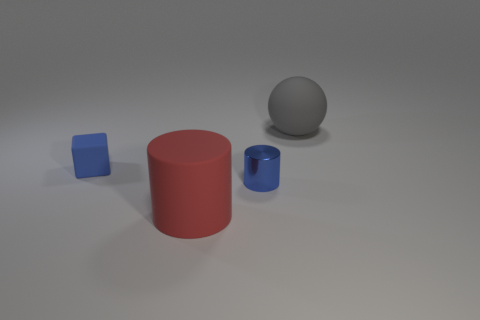Is there any other thing that is made of the same material as the blue cylinder?
Offer a very short reply. No. Is the color of the tiny object on the right side of the red matte thing the same as the large rubber object that is behind the metal cylinder?
Make the answer very short. No. What number of blocks are either tiny brown matte objects or small things?
Provide a succinct answer. 1. Are there the same number of big rubber things that are to the left of the blue cylinder and tiny objects?
Your answer should be very brief. No. What is the big object in front of the rubber thing to the left of the matte thing that is in front of the small blue matte thing made of?
Ensure brevity in your answer.  Rubber. There is a cylinder that is the same color as the rubber cube; what is it made of?
Provide a short and direct response. Metal. What number of objects are either rubber things to the left of the big gray object or metallic cylinders?
Your answer should be compact. 3. How many things are either blue cylinders or matte things behind the metal cylinder?
Give a very brief answer. 3. There is a large thing that is in front of the rubber thing to the right of the blue shiny object; how many large gray things are behind it?
Provide a short and direct response. 1. There is a gray sphere that is the same size as the red matte thing; what material is it?
Ensure brevity in your answer.  Rubber. 